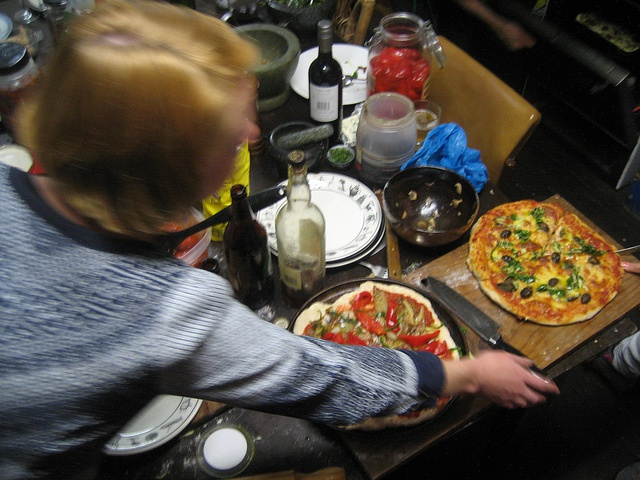Describe the objects in this image and their specific colors. I can see people in black, gray, and darkgray tones, dining table in black, gray, olive, and lightgray tones, pizza in black, red, olive, and orange tones, pizza in black, brown, and tan tones, and chair in black, maroon, and olive tones in this image. 